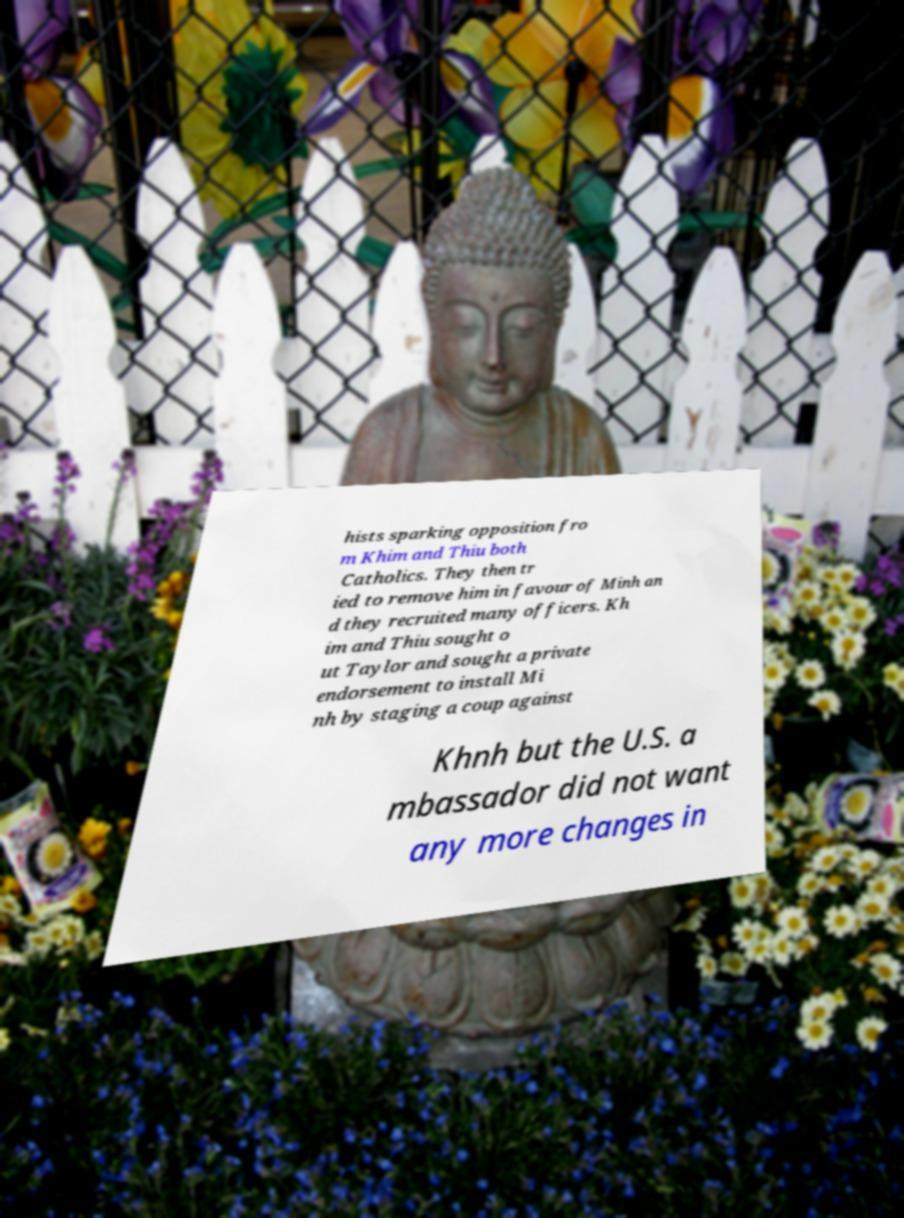Please identify and transcribe the text found in this image. hists sparking opposition fro m Khim and Thiu both Catholics. They then tr ied to remove him in favour of Minh an d they recruited many officers. Kh im and Thiu sought o ut Taylor and sought a private endorsement to install Mi nh by staging a coup against Khnh but the U.S. a mbassador did not want any more changes in 